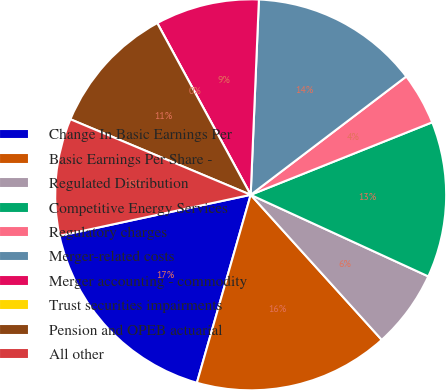Convert chart to OTSL. <chart><loc_0><loc_0><loc_500><loc_500><pie_chart><fcel>Change In Basic Earnings Per<fcel>Basic Earnings Per Share -<fcel>Regulated Distribution<fcel>Competitive Energy Services<fcel>Regulatory charges<fcel>Merger-related costs<fcel>Merger accounting - commodity<fcel>Trust securities impairments<fcel>Pension and OPEB actuarial<fcel>All other<nl><fcel>17.2%<fcel>16.13%<fcel>6.45%<fcel>12.9%<fcel>4.3%<fcel>13.98%<fcel>8.6%<fcel>0.0%<fcel>10.75%<fcel>9.68%<nl></chart> 